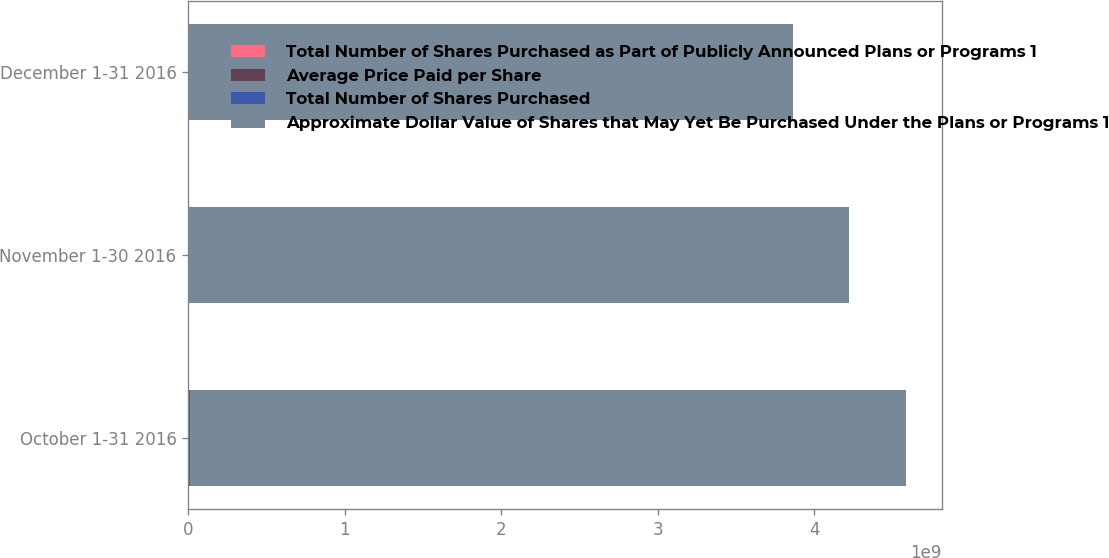Convert chart. <chart><loc_0><loc_0><loc_500><loc_500><stacked_bar_chart><ecel><fcel>October 1-31 2016<fcel>November 1-30 2016<fcel>December 1-31 2016<nl><fcel>Total Number of Shares Purchased as Part of Publicly Announced Plans or Programs 1<fcel>5.90257e+06<fcel>3.07642e+06<fcel>2.91508e+06<nl><fcel>Average Price Paid per Share<fcel>113.43<fcel>116.25<fcel>121.76<nl><fcel>Total Number of Shares Purchased<fcel>5.90257e+06<fcel>3.07642e+06<fcel>2.91508e+06<nl><fcel>Approximate Dollar Value of Shares that May Yet Be Purchased Under the Plans or Programs 1<fcel>4.57114e+09<fcel>4.21351e+09<fcel>3.85857e+09<nl></chart> 